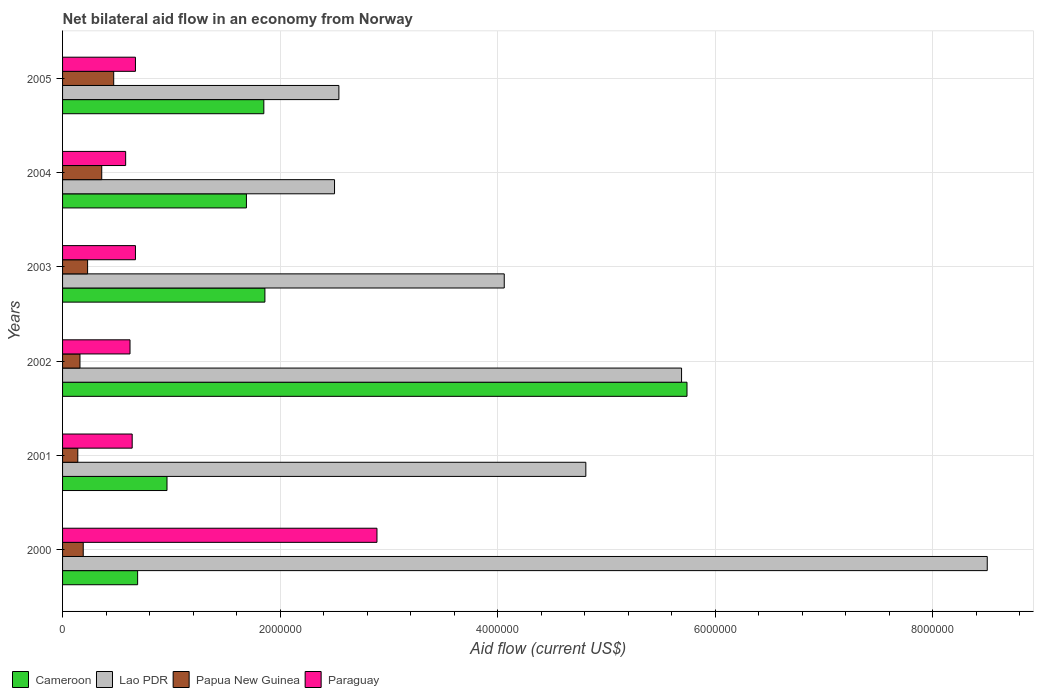How many different coloured bars are there?
Offer a terse response. 4. How many groups of bars are there?
Your answer should be compact. 6. Are the number of bars per tick equal to the number of legend labels?
Your answer should be compact. Yes. Are the number of bars on each tick of the Y-axis equal?
Offer a terse response. Yes. How many bars are there on the 6th tick from the bottom?
Give a very brief answer. 4. What is the label of the 3rd group of bars from the top?
Make the answer very short. 2003. In how many cases, is the number of bars for a given year not equal to the number of legend labels?
Ensure brevity in your answer.  0. What is the net bilateral aid flow in Papua New Guinea in 2005?
Ensure brevity in your answer.  4.70e+05. Across all years, what is the maximum net bilateral aid flow in Paraguay?
Your answer should be compact. 2.89e+06. Across all years, what is the minimum net bilateral aid flow in Lao PDR?
Give a very brief answer. 2.50e+06. In which year was the net bilateral aid flow in Papua New Guinea minimum?
Provide a short and direct response. 2001. What is the total net bilateral aid flow in Lao PDR in the graph?
Your answer should be very brief. 2.81e+07. What is the difference between the net bilateral aid flow in Cameroon in 2001 and that in 2003?
Provide a short and direct response. -9.00e+05. What is the difference between the net bilateral aid flow in Cameroon in 2000 and the net bilateral aid flow in Lao PDR in 2002?
Keep it short and to the point. -5.00e+06. What is the average net bilateral aid flow in Paraguay per year?
Provide a succinct answer. 1.01e+06. In the year 2004, what is the difference between the net bilateral aid flow in Lao PDR and net bilateral aid flow in Papua New Guinea?
Keep it short and to the point. 2.14e+06. What is the ratio of the net bilateral aid flow in Cameroon in 2000 to that in 2004?
Provide a succinct answer. 0.41. What is the difference between the highest and the second highest net bilateral aid flow in Cameroon?
Keep it short and to the point. 3.88e+06. What is the difference between the highest and the lowest net bilateral aid flow in Papua New Guinea?
Make the answer very short. 3.30e+05. Is the sum of the net bilateral aid flow in Paraguay in 2000 and 2005 greater than the maximum net bilateral aid flow in Papua New Guinea across all years?
Provide a succinct answer. Yes. What does the 4th bar from the top in 2000 represents?
Make the answer very short. Cameroon. What does the 4th bar from the bottom in 2005 represents?
Make the answer very short. Paraguay. Is it the case that in every year, the sum of the net bilateral aid flow in Papua New Guinea and net bilateral aid flow in Lao PDR is greater than the net bilateral aid flow in Paraguay?
Your answer should be compact. Yes. How many years are there in the graph?
Give a very brief answer. 6. How are the legend labels stacked?
Ensure brevity in your answer.  Horizontal. What is the title of the graph?
Offer a very short reply. Net bilateral aid flow in an economy from Norway. Does "Grenada" appear as one of the legend labels in the graph?
Provide a short and direct response. No. What is the label or title of the Y-axis?
Offer a terse response. Years. What is the Aid flow (current US$) of Cameroon in 2000?
Your response must be concise. 6.90e+05. What is the Aid flow (current US$) of Lao PDR in 2000?
Ensure brevity in your answer.  8.50e+06. What is the Aid flow (current US$) of Papua New Guinea in 2000?
Provide a short and direct response. 1.90e+05. What is the Aid flow (current US$) of Paraguay in 2000?
Provide a succinct answer. 2.89e+06. What is the Aid flow (current US$) in Cameroon in 2001?
Give a very brief answer. 9.60e+05. What is the Aid flow (current US$) in Lao PDR in 2001?
Provide a short and direct response. 4.81e+06. What is the Aid flow (current US$) in Paraguay in 2001?
Your answer should be compact. 6.40e+05. What is the Aid flow (current US$) of Cameroon in 2002?
Provide a short and direct response. 5.74e+06. What is the Aid flow (current US$) in Lao PDR in 2002?
Provide a short and direct response. 5.69e+06. What is the Aid flow (current US$) of Papua New Guinea in 2002?
Your answer should be compact. 1.60e+05. What is the Aid flow (current US$) of Paraguay in 2002?
Your answer should be very brief. 6.20e+05. What is the Aid flow (current US$) in Cameroon in 2003?
Your answer should be compact. 1.86e+06. What is the Aid flow (current US$) of Lao PDR in 2003?
Keep it short and to the point. 4.06e+06. What is the Aid flow (current US$) of Paraguay in 2003?
Your answer should be very brief. 6.70e+05. What is the Aid flow (current US$) of Cameroon in 2004?
Ensure brevity in your answer.  1.69e+06. What is the Aid flow (current US$) of Lao PDR in 2004?
Your response must be concise. 2.50e+06. What is the Aid flow (current US$) of Paraguay in 2004?
Offer a terse response. 5.80e+05. What is the Aid flow (current US$) of Cameroon in 2005?
Ensure brevity in your answer.  1.85e+06. What is the Aid flow (current US$) of Lao PDR in 2005?
Your response must be concise. 2.54e+06. What is the Aid flow (current US$) of Paraguay in 2005?
Keep it short and to the point. 6.70e+05. Across all years, what is the maximum Aid flow (current US$) of Cameroon?
Ensure brevity in your answer.  5.74e+06. Across all years, what is the maximum Aid flow (current US$) in Lao PDR?
Keep it short and to the point. 8.50e+06. Across all years, what is the maximum Aid flow (current US$) in Papua New Guinea?
Ensure brevity in your answer.  4.70e+05. Across all years, what is the maximum Aid flow (current US$) in Paraguay?
Offer a terse response. 2.89e+06. Across all years, what is the minimum Aid flow (current US$) in Cameroon?
Your answer should be very brief. 6.90e+05. Across all years, what is the minimum Aid flow (current US$) in Lao PDR?
Offer a terse response. 2.50e+06. Across all years, what is the minimum Aid flow (current US$) of Papua New Guinea?
Make the answer very short. 1.40e+05. Across all years, what is the minimum Aid flow (current US$) of Paraguay?
Your answer should be very brief. 5.80e+05. What is the total Aid flow (current US$) of Cameroon in the graph?
Your answer should be compact. 1.28e+07. What is the total Aid flow (current US$) of Lao PDR in the graph?
Offer a terse response. 2.81e+07. What is the total Aid flow (current US$) in Papua New Guinea in the graph?
Provide a succinct answer. 1.55e+06. What is the total Aid flow (current US$) in Paraguay in the graph?
Keep it short and to the point. 6.07e+06. What is the difference between the Aid flow (current US$) in Cameroon in 2000 and that in 2001?
Your response must be concise. -2.70e+05. What is the difference between the Aid flow (current US$) in Lao PDR in 2000 and that in 2001?
Your response must be concise. 3.69e+06. What is the difference between the Aid flow (current US$) in Paraguay in 2000 and that in 2001?
Give a very brief answer. 2.25e+06. What is the difference between the Aid flow (current US$) in Cameroon in 2000 and that in 2002?
Provide a short and direct response. -5.05e+06. What is the difference between the Aid flow (current US$) in Lao PDR in 2000 and that in 2002?
Keep it short and to the point. 2.81e+06. What is the difference between the Aid flow (current US$) of Papua New Guinea in 2000 and that in 2002?
Provide a short and direct response. 3.00e+04. What is the difference between the Aid flow (current US$) of Paraguay in 2000 and that in 2002?
Your answer should be compact. 2.27e+06. What is the difference between the Aid flow (current US$) of Cameroon in 2000 and that in 2003?
Ensure brevity in your answer.  -1.17e+06. What is the difference between the Aid flow (current US$) of Lao PDR in 2000 and that in 2003?
Make the answer very short. 4.44e+06. What is the difference between the Aid flow (current US$) of Papua New Guinea in 2000 and that in 2003?
Give a very brief answer. -4.00e+04. What is the difference between the Aid flow (current US$) of Paraguay in 2000 and that in 2003?
Keep it short and to the point. 2.22e+06. What is the difference between the Aid flow (current US$) of Paraguay in 2000 and that in 2004?
Make the answer very short. 2.31e+06. What is the difference between the Aid flow (current US$) of Cameroon in 2000 and that in 2005?
Provide a short and direct response. -1.16e+06. What is the difference between the Aid flow (current US$) in Lao PDR in 2000 and that in 2005?
Your response must be concise. 5.96e+06. What is the difference between the Aid flow (current US$) of Papua New Guinea in 2000 and that in 2005?
Ensure brevity in your answer.  -2.80e+05. What is the difference between the Aid flow (current US$) in Paraguay in 2000 and that in 2005?
Provide a short and direct response. 2.22e+06. What is the difference between the Aid flow (current US$) in Cameroon in 2001 and that in 2002?
Give a very brief answer. -4.78e+06. What is the difference between the Aid flow (current US$) of Lao PDR in 2001 and that in 2002?
Offer a terse response. -8.80e+05. What is the difference between the Aid flow (current US$) of Papua New Guinea in 2001 and that in 2002?
Your answer should be very brief. -2.00e+04. What is the difference between the Aid flow (current US$) of Paraguay in 2001 and that in 2002?
Provide a succinct answer. 2.00e+04. What is the difference between the Aid flow (current US$) of Cameroon in 2001 and that in 2003?
Ensure brevity in your answer.  -9.00e+05. What is the difference between the Aid flow (current US$) in Lao PDR in 2001 and that in 2003?
Offer a terse response. 7.50e+05. What is the difference between the Aid flow (current US$) of Papua New Guinea in 2001 and that in 2003?
Your answer should be very brief. -9.00e+04. What is the difference between the Aid flow (current US$) in Cameroon in 2001 and that in 2004?
Ensure brevity in your answer.  -7.30e+05. What is the difference between the Aid flow (current US$) in Lao PDR in 2001 and that in 2004?
Make the answer very short. 2.31e+06. What is the difference between the Aid flow (current US$) of Paraguay in 2001 and that in 2004?
Ensure brevity in your answer.  6.00e+04. What is the difference between the Aid flow (current US$) in Cameroon in 2001 and that in 2005?
Give a very brief answer. -8.90e+05. What is the difference between the Aid flow (current US$) of Lao PDR in 2001 and that in 2005?
Offer a very short reply. 2.27e+06. What is the difference between the Aid flow (current US$) in Papua New Guinea in 2001 and that in 2005?
Make the answer very short. -3.30e+05. What is the difference between the Aid flow (current US$) in Cameroon in 2002 and that in 2003?
Your answer should be compact. 3.88e+06. What is the difference between the Aid flow (current US$) in Lao PDR in 2002 and that in 2003?
Your answer should be very brief. 1.63e+06. What is the difference between the Aid flow (current US$) of Papua New Guinea in 2002 and that in 2003?
Keep it short and to the point. -7.00e+04. What is the difference between the Aid flow (current US$) of Cameroon in 2002 and that in 2004?
Give a very brief answer. 4.05e+06. What is the difference between the Aid flow (current US$) of Lao PDR in 2002 and that in 2004?
Your answer should be very brief. 3.19e+06. What is the difference between the Aid flow (current US$) in Paraguay in 2002 and that in 2004?
Your answer should be compact. 4.00e+04. What is the difference between the Aid flow (current US$) in Cameroon in 2002 and that in 2005?
Offer a terse response. 3.89e+06. What is the difference between the Aid flow (current US$) in Lao PDR in 2002 and that in 2005?
Offer a terse response. 3.15e+06. What is the difference between the Aid flow (current US$) in Papua New Guinea in 2002 and that in 2005?
Provide a succinct answer. -3.10e+05. What is the difference between the Aid flow (current US$) of Paraguay in 2002 and that in 2005?
Provide a succinct answer. -5.00e+04. What is the difference between the Aid flow (current US$) of Cameroon in 2003 and that in 2004?
Give a very brief answer. 1.70e+05. What is the difference between the Aid flow (current US$) in Lao PDR in 2003 and that in 2004?
Give a very brief answer. 1.56e+06. What is the difference between the Aid flow (current US$) of Lao PDR in 2003 and that in 2005?
Offer a very short reply. 1.52e+06. What is the difference between the Aid flow (current US$) in Lao PDR in 2004 and that in 2005?
Your answer should be very brief. -4.00e+04. What is the difference between the Aid flow (current US$) of Papua New Guinea in 2004 and that in 2005?
Offer a very short reply. -1.10e+05. What is the difference between the Aid flow (current US$) in Paraguay in 2004 and that in 2005?
Give a very brief answer. -9.00e+04. What is the difference between the Aid flow (current US$) of Cameroon in 2000 and the Aid flow (current US$) of Lao PDR in 2001?
Make the answer very short. -4.12e+06. What is the difference between the Aid flow (current US$) in Cameroon in 2000 and the Aid flow (current US$) in Papua New Guinea in 2001?
Ensure brevity in your answer.  5.50e+05. What is the difference between the Aid flow (current US$) of Cameroon in 2000 and the Aid flow (current US$) of Paraguay in 2001?
Provide a short and direct response. 5.00e+04. What is the difference between the Aid flow (current US$) of Lao PDR in 2000 and the Aid flow (current US$) of Papua New Guinea in 2001?
Provide a succinct answer. 8.36e+06. What is the difference between the Aid flow (current US$) in Lao PDR in 2000 and the Aid flow (current US$) in Paraguay in 2001?
Make the answer very short. 7.86e+06. What is the difference between the Aid flow (current US$) of Papua New Guinea in 2000 and the Aid flow (current US$) of Paraguay in 2001?
Your answer should be compact. -4.50e+05. What is the difference between the Aid flow (current US$) in Cameroon in 2000 and the Aid flow (current US$) in Lao PDR in 2002?
Give a very brief answer. -5.00e+06. What is the difference between the Aid flow (current US$) in Cameroon in 2000 and the Aid flow (current US$) in Papua New Guinea in 2002?
Provide a succinct answer. 5.30e+05. What is the difference between the Aid flow (current US$) in Cameroon in 2000 and the Aid flow (current US$) in Paraguay in 2002?
Offer a terse response. 7.00e+04. What is the difference between the Aid flow (current US$) in Lao PDR in 2000 and the Aid flow (current US$) in Papua New Guinea in 2002?
Your answer should be very brief. 8.34e+06. What is the difference between the Aid flow (current US$) of Lao PDR in 2000 and the Aid flow (current US$) of Paraguay in 2002?
Keep it short and to the point. 7.88e+06. What is the difference between the Aid flow (current US$) of Papua New Guinea in 2000 and the Aid flow (current US$) of Paraguay in 2002?
Make the answer very short. -4.30e+05. What is the difference between the Aid flow (current US$) of Cameroon in 2000 and the Aid flow (current US$) of Lao PDR in 2003?
Your response must be concise. -3.37e+06. What is the difference between the Aid flow (current US$) in Cameroon in 2000 and the Aid flow (current US$) in Papua New Guinea in 2003?
Ensure brevity in your answer.  4.60e+05. What is the difference between the Aid flow (current US$) of Lao PDR in 2000 and the Aid flow (current US$) of Papua New Guinea in 2003?
Your answer should be compact. 8.27e+06. What is the difference between the Aid flow (current US$) in Lao PDR in 2000 and the Aid flow (current US$) in Paraguay in 2003?
Offer a terse response. 7.83e+06. What is the difference between the Aid flow (current US$) in Papua New Guinea in 2000 and the Aid flow (current US$) in Paraguay in 2003?
Provide a short and direct response. -4.80e+05. What is the difference between the Aid flow (current US$) of Cameroon in 2000 and the Aid flow (current US$) of Lao PDR in 2004?
Provide a succinct answer. -1.81e+06. What is the difference between the Aid flow (current US$) in Cameroon in 2000 and the Aid flow (current US$) in Papua New Guinea in 2004?
Offer a very short reply. 3.30e+05. What is the difference between the Aid flow (current US$) in Cameroon in 2000 and the Aid flow (current US$) in Paraguay in 2004?
Make the answer very short. 1.10e+05. What is the difference between the Aid flow (current US$) in Lao PDR in 2000 and the Aid flow (current US$) in Papua New Guinea in 2004?
Your response must be concise. 8.14e+06. What is the difference between the Aid flow (current US$) of Lao PDR in 2000 and the Aid flow (current US$) of Paraguay in 2004?
Make the answer very short. 7.92e+06. What is the difference between the Aid flow (current US$) in Papua New Guinea in 2000 and the Aid flow (current US$) in Paraguay in 2004?
Make the answer very short. -3.90e+05. What is the difference between the Aid flow (current US$) in Cameroon in 2000 and the Aid flow (current US$) in Lao PDR in 2005?
Provide a succinct answer. -1.85e+06. What is the difference between the Aid flow (current US$) in Cameroon in 2000 and the Aid flow (current US$) in Papua New Guinea in 2005?
Provide a short and direct response. 2.20e+05. What is the difference between the Aid flow (current US$) of Cameroon in 2000 and the Aid flow (current US$) of Paraguay in 2005?
Make the answer very short. 2.00e+04. What is the difference between the Aid flow (current US$) in Lao PDR in 2000 and the Aid flow (current US$) in Papua New Guinea in 2005?
Provide a short and direct response. 8.03e+06. What is the difference between the Aid flow (current US$) in Lao PDR in 2000 and the Aid flow (current US$) in Paraguay in 2005?
Offer a very short reply. 7.83e+06. What is the difference between the Aid flow (current US$) in Papua New Guinea in 2000 and the Aid flow (current US$) in Paraguay in 2005?
Ensure brevity in your answer.  -4.80e+05. What is the difference between the Aid flow (current US$) in Cameroon in 2001 and the Aid flow (current US$) in Lao PDR in 2002?
Give a very brief answer. -4.73e+06. What is the difference between the Aid flow (current US$) in Cameroon in 2001 and the Aid flow (current US$) in Papua New Guinea in 2002?
Give a very brief answer. 8.00e+05. What is the difference between the Aid flow (current US$) in Cameroon in 2001 and the Aid flow (current US$) in Paraguay in 2002?
Keep it short and to the point. 3.40e+05. What is the difference between the Aid flow (current US$) in Lao PDR in 2001 and the Aid flow (current US$) in Papua New Guinea in 2002?
Offer a terse response. 4.65e+06. What is the difference between the Aid flow (current US$) of Lao PDR in 2001 and the Aid flow (current US$) of Paraguay in 2002?
Give a very brief answer. 4.19e+06. What is the difference between the Aid flow (current US$) of Papua New Guinea in 2001 and the Aid flow (current US$) of Paraguay in 2002?
Give a very brief answer. -4.80e+05. What is the difference between the Aid flow (current US$) of Cameroon in 2001 and the Aid flow (current US$) of Lao PDR in 2003?
Your answer should be very brief. -3.10e+06. What is the difference between the Aid flow (current US$) of Cameroon in 2001 and the Aid flow (current US$) of Papua New Guinea in 2003?
Your answer should be compact. 7.30e+05. What is the difference between the Aid flow (current US$) of Lao PDR in 2001 and the Aid flow (current US$) of Papua New Guinea in 2003?
Ensure brevity in your answer.  4.58e+06. What is the difference between the Aid flow (current US$) in Lao PDR in 2001 and the Aid flow (current US$) in Paraguay in 2003?
Ensure brevity in your answer.  4.14e+06. What is the difference between the Aid flow (current US$) in Papua New Guinea in 2001 and the Aid flow (current US$) in Paraguay in 2003?
Make the answer very short. -5.30e+05. What is the difference between the Aid flow (current US$) of Cameroon in 2001 and the Aid flow (current US$) of Lao PDR in 2004?
Offer a terse response. -1.54e+06. What is the difference between the Aid flow (current US$) in Lao PDR in 2001 and the Aid flow (current US$) in Papua New Guinea in 2004?
Offer a very short reply. 4.45e+06. What is the difference between the Aid flow (current US$) in Lao PDR in 2001 and the Aid flow (current US$) in Paraguay in 2004?
Offer a terse response. 4.23e+06. What is the difference between the Aid flow (current US$) in Papua New Guinea in 2001 and the Aid flow (current US$) in Paraguay in 2004?
Your answer should be compact. -4.40e+05. What is the difference between the Aid flow (current US$) in Cameroon in 2001 and the Aid flow (current US$) in Lao PDR in 2005?
Your answer should be very brief. -1.58e+06. What is the difference between the Aid flow (current US$) in Lao PDR in 2001 and the Aid flow (current US$) in Papua New Guinea in 2005?
Ensure brevity in your answer.  4.34e+06. What is the difference between the Aid flow (current US$) of Lao PDR in 2001 and the Aid flow (current US$) of Paraguay in 2005?
Your answer should be very brief. 4.14e+06. What is the difference between the Aid flow (current US$) of Papua New Guinea in 2001 and the Aid flow (current US$) of Paraguay in 2005?
Provide a short and direct response. -5.30e+05. What is the difference between the Aid flow (current US$) in Cameroon in 2002 and the Aid flow (current US$) in Lao PDR in 2003?
Provide a succinct answer. 1.68e+06. What is the difference between the Aid flow (current US$) of Cameroon in 2002 and the Aid flow (current US$) of Papua New Guinea in 2003?
Your response must be concise. 5.51e+06. What is the difference between the Aid flow (current US$) of Cameroon in 2002 and the Aid flow (current US$) of Paraguay in 2003?
Offer a terse response. 5.07e+06. What is the difference between the Aid flow (current US$) of Lao PDR in 2002 and the Aid flow (current US$) of Papua New Guinea in 2003?
Offer a very short reply. 5.46e+06. What is the difference between the Aid flow (current US$) of Lao PDR in 2002 and the Aid flow (current US$) of Paraguay in 2003?
Keep it short and to the point. 5.02e+06. What is the difference between the Aid flow (current US$) of Papua New Guinea in 2002 and the Aid flow (current US$) of Paraguay in 2003?
Provide a short and direct response. -5.10e+05. What is the difference between the Aid flow (current US$) of Cameroon in 2002 and the Aid flow (current US$) of Lao PDR in 2004?
Provide a succinct answer. 3.24e+06. What is the difference between the Aid flow (current US$) of Cameroon in 2002 and the Aid flow (current US$) of Papua New Guinea in 2004?
Give a very brief answer. 5.38e+06. What is the difference between the Aid flow (current US$) in Cameroon in 2002 and the Aid flow (current US$) in Paraguay in 2004?
Ensure brevity in your answer.  5.16e+06. What is the difference between the Aid flow (current US$) in Lao PDR in 2002 and the Aid flow (current US$) in Papua New Guinea in 2004?
Offer a very short reply. 5.33e+06. What is the difference between the Aid flow (current US$) in Lao PDR in 2002 and the Aid flow (current US$) in Paraguay in 2004?
Provide a short and direct response. 5.11e+06. What is the difference between the Aid flow (current US$) of Papua New Guinea in 2002 and the Aid flow (current US$) of Paraguay in 2004?
Provide a succinct answer. -4.20e+05. What is the difference between the Aid flow (current US$) of Cameroon in 2002 and the Aid flow (current US$) of Lao PDR in 2005?
Provide a succinct answer. 3.20e+06. What is the difference between the Aid flow (current US$) of Cameroon in 2002 and the Aid flow (current US$) of Papua New Guinea in 2005?
Offer a very short reply. 5.27e+06. What is the difference between the Aid flow (current US$) in Cameroon in 2002 and the Aid flow (current US$) in Paraguay in 2005?
Your answer should be very brief. 5.07e+06. What is the difference between the Aid flow (current US$) of Lao PDR in 2002 and the Aid flow (current US$) of Papua New Guinea in 2005?
Offer a terse response. 5.22e+06. What is the difference between the Aid flow (current US$) of Lao PDR in 2002 and the Aid flow (current US$) of Paraguay in 2005?
Give a very brief answer. 5.02e+06. What is the difference between the Aid flow (current US$) in Papua New Guinea in 2002 and the Aid flow (current US$) in Paraguay in 2005?
Provide a succinct answer. -5.10e+05. What is the difference between the Aid flow (current US$) of Cameroon in 2003 and the Aid flow (current US$) of Lao PDR in 2004?
Your response must be concise. -6.40e+05. What is the difference between the Aid flow (current US$) of Cameroon in 2003 and the Aid flow (current US$) of Papua New Guinea in 2004?
Offer a very short reply. 1.50e+06. What is the difference between the Aid flow (current US$) of Cameroon in 2003 and the Aid flow (current US$) of Paraguay in 2004?
Provide a succinct answer. 1.28e+06. What is the difference between the Aid flow (current US$) in Lao PDR in 2003 and the Aid flow (current US$) in Papua New Guinea in 2004?
Give a very brief answer. 3.70e+06. What is the difference between the Aid flow (current US$) in Lao PDR in 2003 and the Aid flow (current US$) in Paraguay in 2004?
Your answer should be compact. 3.48e+06. What is the difference between the Aid flow (current US$) in Papua New Guinea in 2003 and the Aid flow (current US$) in Paraguay in 2004?
Offer a very short reply. -3.50e+05. What is the difference between the Aid flow (current US$) of Cameroon in 2003 and the Aid flow (current US$) of Lao PDR in 2005?
Give a very brief answer. -6.80e+05. What is the difference between the Aid flow (current US$) of Cameroon in 2003 and the Aid flow (current US$) of Papua New Guinea in 2005?
Give a very brief answer. 1.39e+06. What is the difference between the Aid flow (current US$) in Cameroon in 2003 and the Aid flow (current US$) in Paraguay in 2005?
Provide a short and direct response. 1.19e+06. What is the difference between the Aid flow (current US$) in Lao PDR in 2003 and the Aid flow (current US$) in Papua New Guinea in 2005?
Your answer should be compact. 3.59e+06. What is the difference between the Aid flow (current US$) in Lao PDR in 2003 and the Aid flow (current US$) in Paraguay in 2005?
Make the answer very short. 3.39e+06. What is the difference between the Aid flow (current US$) of Papua New Guinea in 2003 and the Aid flow (current US$) of Paraguay in 2005?
Ensure brevity in your answer.  -4.40e+05. What is the difference between the Aid flow (current US$) in Cameroon in 2004 and the Aid flow (current US$) in Lao PDR in 2005?
Offer a very short reply. -8.50e+05. What is the difference between the Aid flow (current US$) in Cameroon in 2004 and the Aid flow (current US$) in Papua New Guinea in 2005?
Your response must be concise. 1.22e+06. What is the difference between the Aid flow (current US$) of Cameroon in 2004 and the Aid flow (current US$) of Paraguay in 2005?
Offer a terse response. 1.02e+06. What is the difference between the Aid flow (current US$) in Lao PDR in 2004 and the Aid flow (current US$) in Papua New Guinea in 2005?
Make the answer very short. 2.03e+06. What is the difference between the Aid flow (current US$) in Lao PDR in 2004 and the Aid flow (current US$) in Paraguay in 2005?
Keep it short and to the point. 1.83e+06. What is the difference between the Aid flow (current US$) of Papua New Guinea in 2004 and the Aid flow (current US$) of Paraguay in 2005?
Provide a succinct answer. -3.10e+05. What is the average Aid flow (current US$) of Cameroon per year?
Your response must be concise. 2.13e+06. What is the average Aid flow (current US$) of Lao PDR per year?
Your response must be concise. 4.68e+06. What is the average Aid flow (current US$) in Papua New Guinea per year?
Offer a very short reply. 2.58e+05. What is the average Aid flow (current US$) in Paraguay per year?
Make the answer very short. 1.01e+06. In the year 2000, what is the difference between the Aid flow (current US$) in Cameroon and Aid flow (current US$) in Lao PDR?
Your answer should be compact. -7.81e+06. In the year 2000, what is the difference between the Aid flow (current US$) in Cameroon and Aid flow (current US$) in Papua New Guinea?
Make the answer very short. 5.00e+05. In the year 2000, what is the difference between the Aid flow (current US$) in Cameroon and Aid flow (current US$) in Paraguay?
Ensure brevity in your answer.  -2.20e+06. In the year 2000, what is the difference between the Aid flow (current US$) of Lao PDR and Aid flow (current US$) of Papua New Guinea?
Provide a succinct answer. 8.31e+06. In the year 2000, what is the difference between the Aid flow (current US$) of Lao PDR and Aid flow (current US$) of Paraguay?
Offer a terse response. 5.61e+06. In the year 2000, what is the difference between the Aid flow (current US$) in Papua New Guinea and Aid flow (current US$) in Paraguay?
Your response must be concise. -2.70e+06. In the year 2001, what is the difference between the Aid flow (current US$) in Cameroon and Aid flow (current US$) in Lao PDR?
Your answer should be compact. -3.85e+06. In the year 2001, what is the difference between the Aid flow (current US$) of Cameroon and Aid flow (current US$) of Papua New Guinea?
Offer a terse response. 8.20e+05. In the year 2001, what is the difference between the Aid flow (current US$) in Lao PDR and Aid flow (current US$) in Papua New Guinea?
Your answer should be compact. 4.67e+06. In the year 2001, what is the difference between the Aid flow (current US$) in Lao PDR and Aid flow (current US$) in Paraguay?
Offer a very short reply. 4.17e+06. In the year 2001, what is the difference between the Aid flow (current US$) in Papua New Guinea and Aid flow (current US$) in Paraguay?
Your answer should be very brief. -5.00e+05. In the year 2002, what is the difference between the Aid flow (current US$) in Cameroon and Aid flow (current US$) in Papua New Guinea?
Offer a very short reply. 5.58e+06. In the year 2002, what is the difference between the Aid flow (current US$) in Cameroon and Aid flow (current US$) in Paraguay?
Provide a short and direct response. 5.12e+06. In the year 2002, what is the difference between the Aid flow (current US$) of Lao PDR and Aid flow (current US$) of Papua New Guinea?
Give a very brief answer. 5.53e+06. In the year 2002, what is the difference between the Aid flow (current US$) in Lao PDR and Aid flow (current US$) in Paraguay?
Ensure brevity in your answer.  5.07e+06. In the year 2002, what is the difference between the Aid flow (current US$) in Papua New Guinea and Aid flow (current US$) in Paraguay?
Offer a terse response. -4.60e+05. In the year 2003, what is the difference between the Aid flow (current US$) in Cameroon and Aid flow (current US$) in Lao PDR?
Give a very brief answer. -2.20e+06. In the year 2003, what is the difference between the Aid flow (current US$) in Cameroon and Aid flow (current US$) in Papua New Guinea?
Make the answer very short. 1.63e+06. In the year 2003, what is the difference between the Aid flow (current US$) of Cameroon and Aid flow (current US$) of Paraguay?
Your response must be concise. 1.19e+06. In the year 2003, what is the difference between the Aid flow (current US$) in Lao PDR and Aid flow (current US$) in Papua New Guinea?
Give a very brief answer. 3.83e+06. In the year 2003, what is the difference between the Aid flow (current US$) of Lao PDR and Aid flow (current US$) of Paraguay?
Your response must be concise. 3.39e+06. In the year 2003, what is the difference between the Aid flow (current US$) of Papua New Guinea and Aid flow (current US$) of Paraguay?
Provide a succinct answer. -4.40e+05. In the year 2004, what is the difference between the Aid flow (current US$) of Cameroon and Aid flow (current US$) of Lao PDR?
Your answer should be very brief. -8.10e+05. In the year 2004, what is the difference between the Aid flow (current US$) in Cameroon and Aid flow (current US$) in Papua New Guinea?
Ensure brevity in your answer.  1.33e+06. In the year 2004, what is the difference between the Aid flow (current US$) of Cameroon and Aid flow (current US$) of Paraguay?
Offer a terse response. 1.11e+06. In the year 2004, what is the difference between the Aid flow (current US$) in Lao PDR and Aid flow (current US$) in Papua New Guinea?
Make the answer very short. 2.14e+06. In the year 2004, what is the difference between the Aid flow (current US$) in Lao PDR and Aid flow (current US$) in Paraguay?
Offer a very short reply. 1.92e+06. In the year 2004, what is the difference between the Aid flow (current US$) in Papua New Guinea and Aid flow (current US$) in Paraguay?
Provide a succinct answer. -2.20e+05. In the year 2005, what is the difference between the Aid flow (current US$) in Cameroon and Aid flow (current US$) in Lao PDR?
Offer a terse response. -6.90e+05. In the year 2005, what is the difference between the Aid flow (current US$) in Cameroon and Aid flow (current US$) in Papua New Guinea?
Ensure brevity in your answer.  1.38e+06. In the year 2005, what is the difference between the Aid flow (current US$) of Cameroon and Aid flow (current US$) of Paraguay?
Keep it short and to the point. 1.18e+06. In the year 2005, what is the difference between the Aid flow (current US$) of Lao PDR and Aid flow (current US$) of Papua New Guinea?
Offer a terse response. 2.07e+06. In the year 2005, what is the difference between the Aid flow (current US$) in Lao PDR and Aid flow (current US$) in Paraguay?
Give a very brief answer. 1.87e+06. In the year 2005, what is the difference between the Aid flow (current US$) of Papua New Guinea and Aid flow (current US$) of Paraguay?
Your answer should be very brief. -2.00e+05. What is the ratio of the Aid flow (current US$) in Cameroon in 2000 to that in 2001?
Keep it short and to the point. 0.72. What is the ratio of the Aid flow (current US$) in Lao PDR in 2000 to that in 2001?
Your answer should be compact. 1.77. What is the ratio of the Aid flow (current US$) in Papua New Guinea in 2000 to that in 2001?
Your answer should be very brief. 1.36. What is the ratio of the Aid flow (current US$) in Paraguay in 2000 to that in 2001?
Offer a terse response. 4.52. What is the ratio of the Aid flow (current US$) in Cameroon in 2000 to that in 2002?
Ensure brevity in your answer.  0.12. What is the ratio of the Aid flow (current US$) of Lao PDR in 2000 to that in 2002?
Ensure brevity in your answer.  1.49. What is the ratio of the Aid flow (current US$) in Papua New Guinea in 2000 to that in 2002?
Ensure brevity in your answer.  1.19. What is the ratio of the Aid flow (current US$) in Paraguay in 2000 to that in 2002?
Your answer should be very brief. 4.66. What is the ratio of the Aid flow (current US$) in Cameroon in 2000 to that in 2003?
Your answer should be compact. 0.37. What is the ratio of the Aid flow (current US$) in Lao PDR in 2000 to that in 2003?
Keep it short and to the point. 2.09. What is the ratio of the Aid flow (current US$) in Papua New Guinea in 2000 to that in 2003?
Keep it short and to the point. 0.83. What is the ratio of the Aid flow (current US$) in Paraguay in 2000 to that in 2003?
Provide a succinct answer. 4.31. What is the ratio of the Aid flow (current US$) of Cameroon in 2000 to that in 2004?
Offer a terse response. 0.41. What is the ratio of the Aid flow (current US$) in Lao PDR in 2000 to that in 2004?
Provide a short and direct response. 3.4. What is the ratio of the Aid flow (current US$) of Papua New Guinea in 2000 to that in 2004?
Give a very brief answer. 0.53. What is the ratio of the Aid flow (current US$) of Paraguay in 2000 to that in 2004?
Offer a terse response. 4.98. What is the ratio of the Aid flow (current US$) in Cameroon in 2000 to that in 2005?
Your answer should be very brief. 0.37. What is the ratio of the Aid flow (current US$) of Lao PDR in 2000 to that in 2005?
Offer a very short reply. 3.35. What is the ratio of the Aid flow (current US$) in Papua New Guinea in 2000 to that in 2005?
Give a very brief answer. 0.4. What is the ratio of the Aid flow (current US$) in Paraguay in 2000 to that in 2005?
Make the answer very short. 4.31. What is the ratio of the Aid flow (current US$) in Cameroon in 2001 to that in 2002?
Your answer should be compact. 0.17. What is the ratio of the Aid flow (current US$) of Lao PDR in 2001 to that in 2002?
Keep it short and to the point. 0.85. What is the ratio of the Aid flow (current US$) in Paraguay in 2001 to that in 2002?
Keep it short and to the point. 1.03. What is the ratio of the Aid flow (current US$) in Cameroon in 2001 to that in 2003?
Your answer should be very brief. 0.52. What is the ratio of the Aid flow (current US$) in Lao PDR in 2001 to that in 2003?
Your response must be concise. 1.18. What is the ratio of the Aid flow (current US$) of Papua New Guinea in 2001 to that in 2003?
Provide a succinct answer. 0.61. What is the ratio of the Aid flow (current US$) in Paraguay in 2001 to that in 2003?
Give a very brief answer. 0.96. What is the ratio of the Aid flow (current US$) of Cameroon in 2001 to that in 2004?
Your answer should be compact. 0.57. What is the ratio of the Aid flow (current US$) in Lao PDR in 2001 to that in 2004?
Provide a short and direct response. 1.92. What is the ratio of the Aid flow (current US$) in Papua New Guinea in 2001 to that in 2004?
Ensure brevity in your answer.  0.39. What is the ratio of the Aid flow (current US$) of Paraguay in 2001 to that in 2004?
Your answer should be very brief. 1.1. What is the ratio of the Aid flow (current US$) of Cameroon in 2001 to that in 2005?
Your answer should be compact. 0.52. What is the ratio of the Aid flow (current US$) of Lao PDR in 2001 to that in 2005?
Provide a succinct answer. 1.89. What is the ratio of the Aid flow (current US$) in Papua New Guinea in 2001 to that in 2005?
Provide a short and direct response. 0.3. What is the ratio of the Aid flow (current US$) of Paraguay in 2001 to that in 2005?
Your answer should be very brief. 0.96. What is the ratio of the Aid flow (current US$) in Cameroon in 2002 to that in 2003?
Offer a terse response. 3.09. What is the ratio of the Aid flow (current US$) in Lao PDR in 2002 to that in 2003?
Offer a very short reply. 1.4. What is the ratio of the Aid flow (current US$) in Papua New Guinea in 2002 to that in 2003?
Provide a succinct answer. 0.7. What is the ratio of the Aid flow (current US$) of Paraguay in 2002 to that in 2003?
Provide a succinct answer. 0.93. What is the ratio of the Aid flow (current US$) in Cameroon in 2002 to that in 2004?
Keep it short and to the point. 3.4. What is the ratio of the Aid flow (current US$) of Lao PDR in 2002 to that in 2004?
Offer a terse response. 2.28. What is the ratio of the Aid flow (current US$) in Papua New Guinea in 2002 to that in 2004?
Give a very brief answer. 0.44. What is the ratio of the Aid flow (current US$) in Paraguay in 2002 to that in 2004?
Provide a succinct answer. 1.07. What is the ratio of the Aid flow (current US$) of Cameroon in 2002 to that in 2005?
Ensure brevity in your answer.  3.1. What is the ratio of the Aid flow (current US$) in Lao PDR in 2002 to that in 2005?
Ensure brevity in your answer.  2.24. What is the ratio of the Aid flow (current US$) in Papua New Guinea in 2002 to that in 2005?
Your answer should be very brief. 0.34. What is the ratio of the Aid flow (current US$) in Paraguay in 2002 to that in 2005?
Provide a short and direct response. 0.93. What is the ratio of the Aid flow (current US$) in Cameroon in 2003 to that in 2004?
Provide a succinct answer. 1.1. What is the ratio of the Aid flow (current US$) of Lao PDR in 2003 to that in 2004?
Your answer should be compact. 1.62. What is the ratio of the Aid flow (current US$) of Papua New Guinea in 2003 to that in 2004?
Your response must be concise. 0.64. What is the ratio of the Aid flow (current US$) in Paraguay in 2003 to that in 2004?
Your response must be concise. 1.16. What is the ratio of the Aid flow (current US$) of Cameroon in 2003 to that in 2005?
Your answer should be very brief. 1.01. What is the ratio of the Aid flow (current US$) of Lao PDR in 2003 to that in 2005?
Offer a very short reply. 1.6. What is the ratio of the Aid flow (current US$) in Papua New Guinea in 2003 to that in 2005?
Provide a short and direct response. 0.49. What is the ratio of the Aid flow (current US$) of Cameroon in 2004 to that in 2005?
Offer a terse response. 0.91. What is the ratio of the Aid flow (current US$) in Lao PDR in 2004 to that in 2005?
Offer a terse response. 0.98. What is the ratio of the Aid flow (current US$) in Papua New Guinea in 2004 to that in 2005?
Offer a very short reply. 0.77. What is the ratio of the Aid flow (current US$) in Paraguay in 2004 to that in 2005?
Offer a very short reply. 0.87. What is the difference between the highest and the second highest Aid flow (current US$) in Cameroon?
Your answer should be compact. 3.88e+06. What is the difference between the highest and the second highest Aid flow (current US$) of Lao PDR?
Give a very brief answer. 2.81e+06. What is the difference between the highest and the second highest Aid flow (current US$) of Paraguay?
Offer a very short reply. 2.22e+06. What is the difference between the highest and the lowest Aid flow (current US$) in Cameroon?
Provide a succinct answer. 5.05e+06. What is the difference between the highest and the lowest Aid flow (current US$) in Paraguay?
Give a very brief answer. 2.31e+06. 